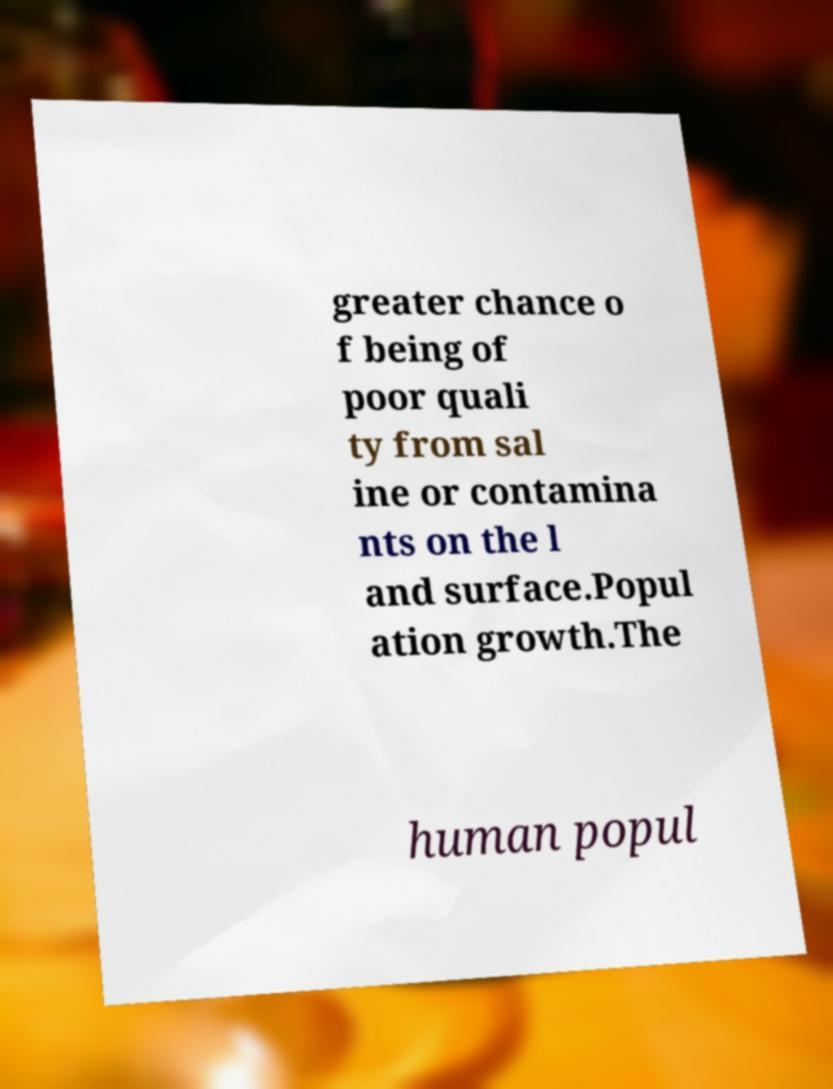I need the written content from this picture converted into text. Can you do that? greater chance o f being of poor quali ty from sal ine or contamina nts on the l and surface.Popul ation growth.The human popul 